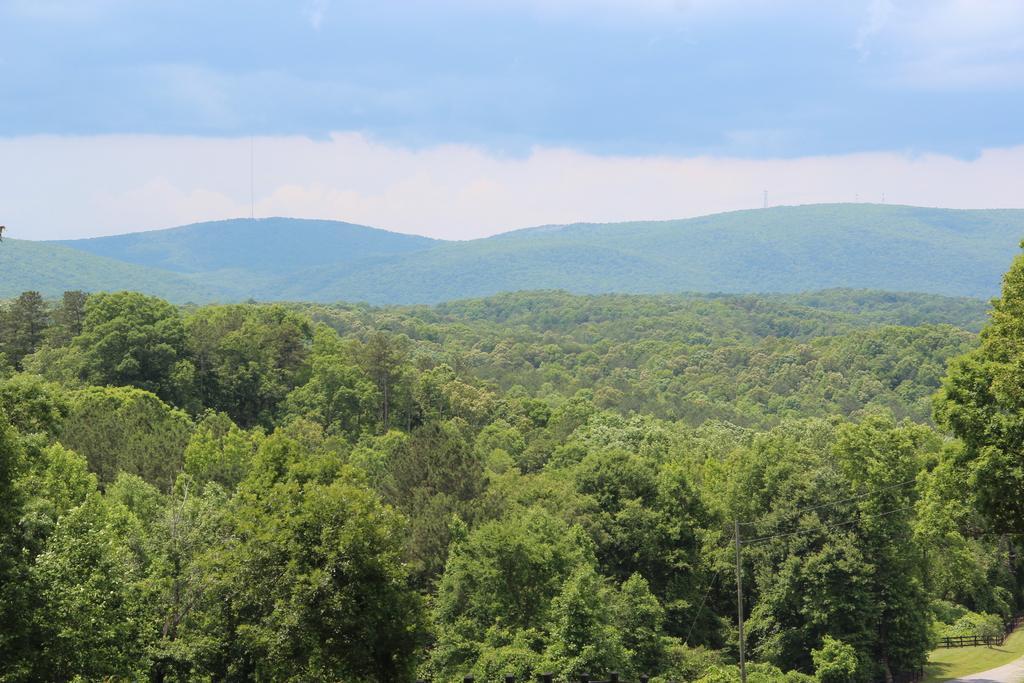Can you describe this image briefly? This image consists of many trees. In the background, there is a mountain. At the top, there are clouds in the sky. 